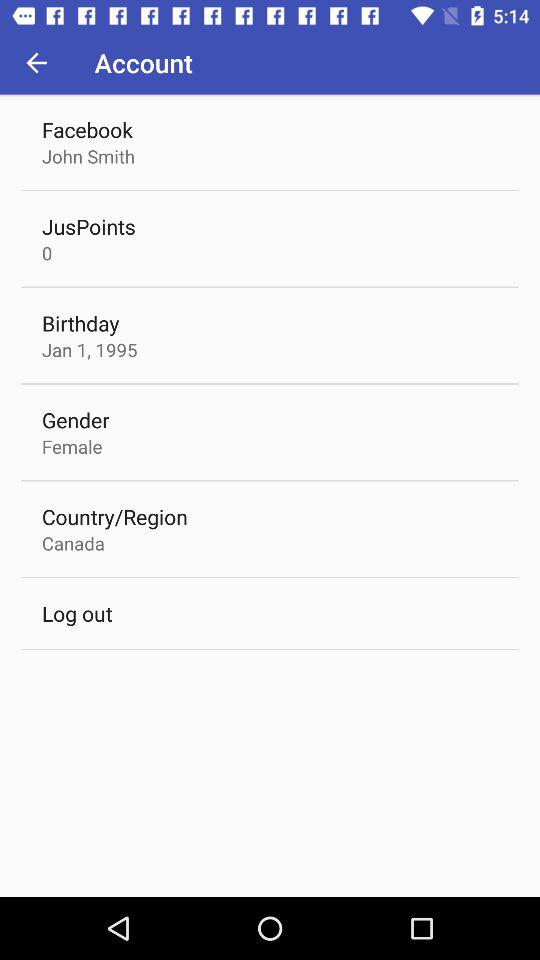What is the date of birth? The date of birth is 1st January, 1995. 